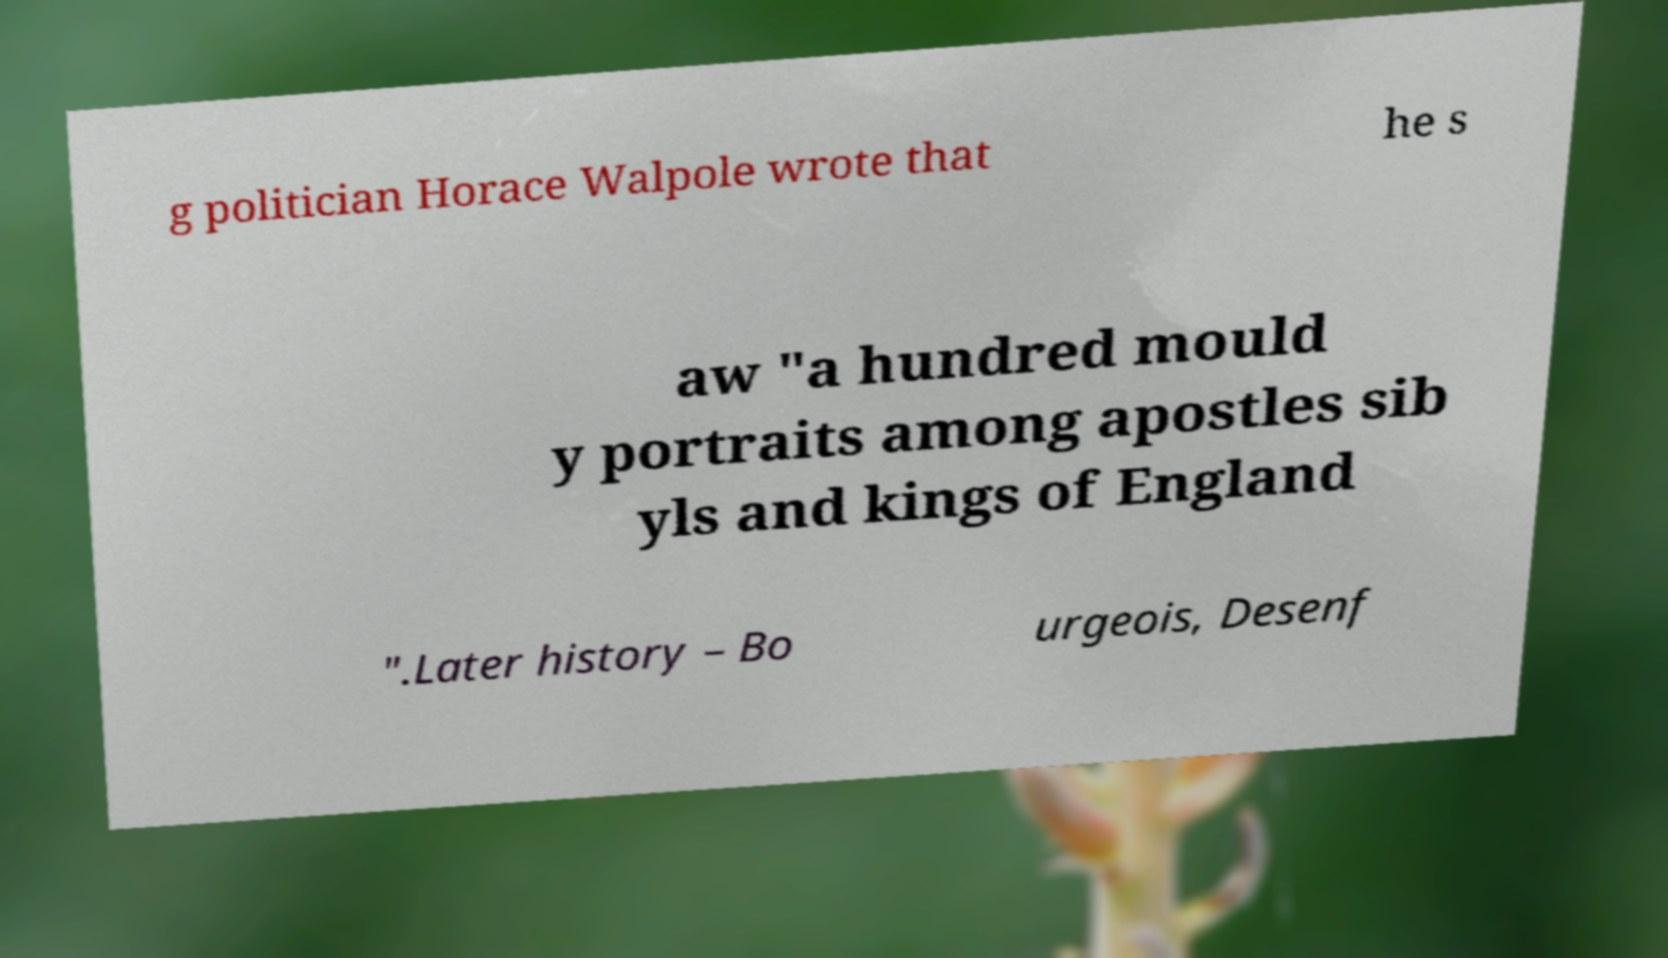There's text embedded in this image that I need extracted. Can you transcribe it verbatim? g politician Horace Walpole wrote that he s aw "a hundred mould y portraits among apostles sib yls and kings of England ".Later history – Bo urgeois, Desenf 